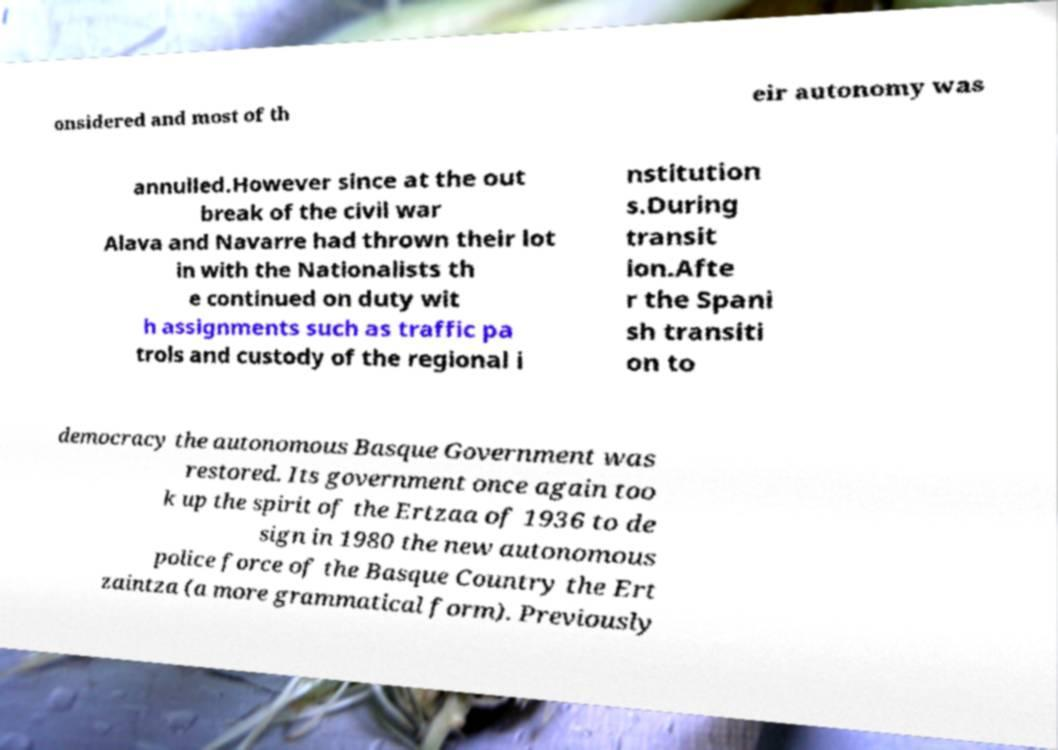Could you extract and type out the text from this image? onsidered and most of th eir autonomy was annulled.However since at the out break of the civil war Alava and Navarre had thrown their lot in with the Nationalists th e continued on duty wit h assignments such as traffic pa trols and custody of the regional i nstitution s.During transit ion.Afte r the Spani sh transiti on to democracy the autonomous Basque Government was restored. Its government once again too k up the spirit of the Ertzaa of 1936 to de sign in 1980 the new autonomous police force of the Basque Country the Ert zaintza (a more grammatical form). Previously 